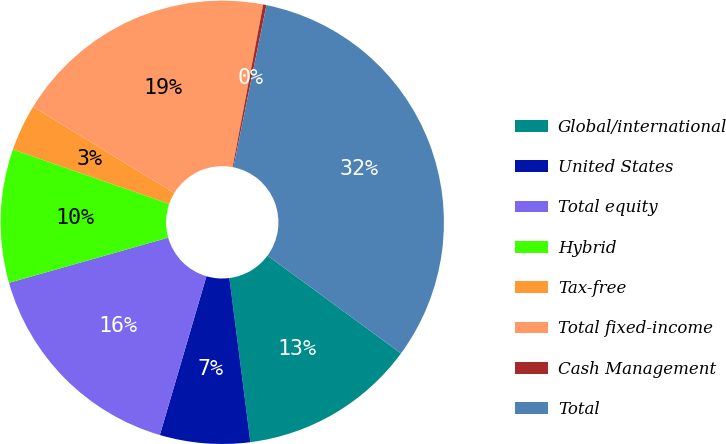Convert chart. <chart><loc_0><loc_0><loc_500><loc_500><pie_chart><fcel>Global/international<fcel>United States<fcel>Total equity<fcel>Hybrid<fcel>Tax-free<fcel>Total fixed-income<fcel>Cash Management<fcel>Total<nl><fcel>12.9%<fcel>6.57%<fcel>16.06%<fcel>9.73%<fcel>3.4%<fcel>19.23%<fcel>0.24%<fcel>31.88%<nl></chart> 